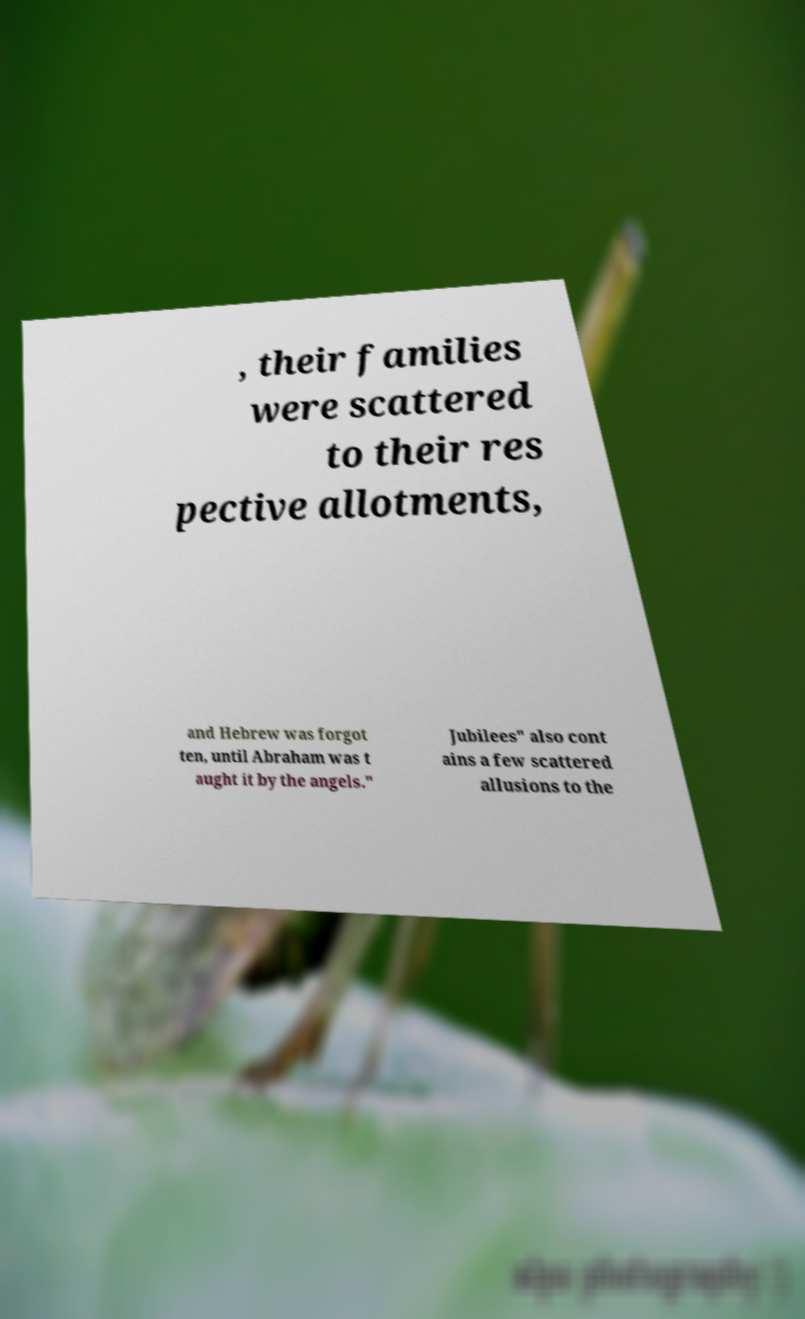Please read and relay the text visible in this image. What does it say? , their families were scattered to their res pective allotments, and Hebrew was forgot ten, until Abraham was t aught it by the angels." Jubilees" also cont ains a few scattered allusions to the 